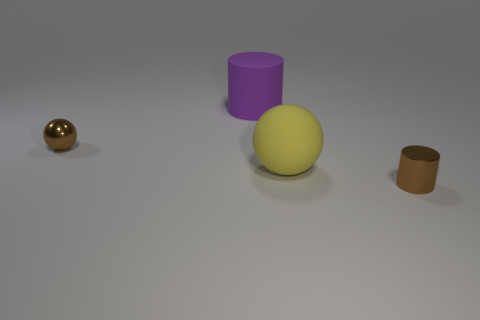Add 4 large spheres. How many objects exist? 8 Subtract 1 cylinders. How many cylinders are left? 1 Subtract all brown cylinders. How many cylinders are left? 1 Subtract all red cylinders. Subtract all gray blocks. How many cylinders are left? 2 Subtract all gray cylinders. How many yellow spheres are left? 1 Subtract all brown things. Subtract all big yellow rubber balls. How many objects are left? 1 Add 3 metallic cylinders. How many metallic cylinders are left? 4 Add 3 rubber objects. How many rubber objects exist? 5 Subtract 0 blue cylinders. How many objects are left? 4 